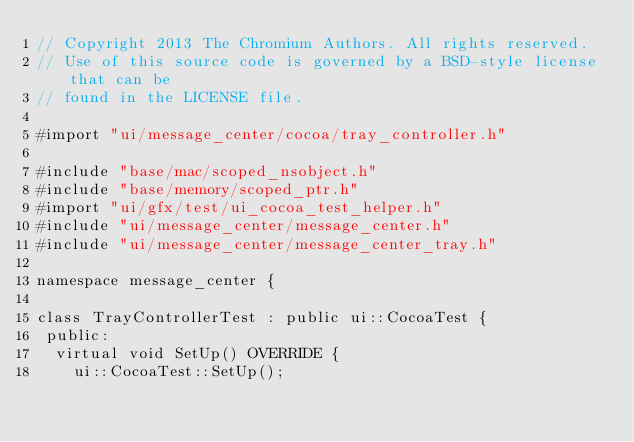<code> <loc_0><loc_0><loc_500><loc_500><_ObjectiveC_>// Copyright 2013 The Chromium Authors. All rights reserved.
// Use of this source code is governed by a BSD-style license that can be
// found in the LICENSE file.

#import "ui/message_center/cocoa/tray_controller.h"

#include "base/mac/scoped_nsobject.h"
#include "base/memory/scoped_ptr.h"
#import "ui/gfx/test/ui_cocoa_test_helper.h"
#include "ui/message_center/message_center.h"
#include "ui/message_center/message_center_tray.h"

namespace message_center {

class TrayControllerTest : public ui::CocoaTest {
 public:
  virtual void SetUp() OVERRIDE {
    ui::CocoaTest::SetUp();</code> 